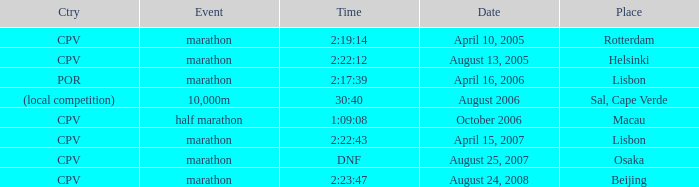What is the Place of the half marathon Event? Macau. 